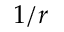<formula> <loc_0><loc_0><loc_500><loc_500>1 / r</formula> 